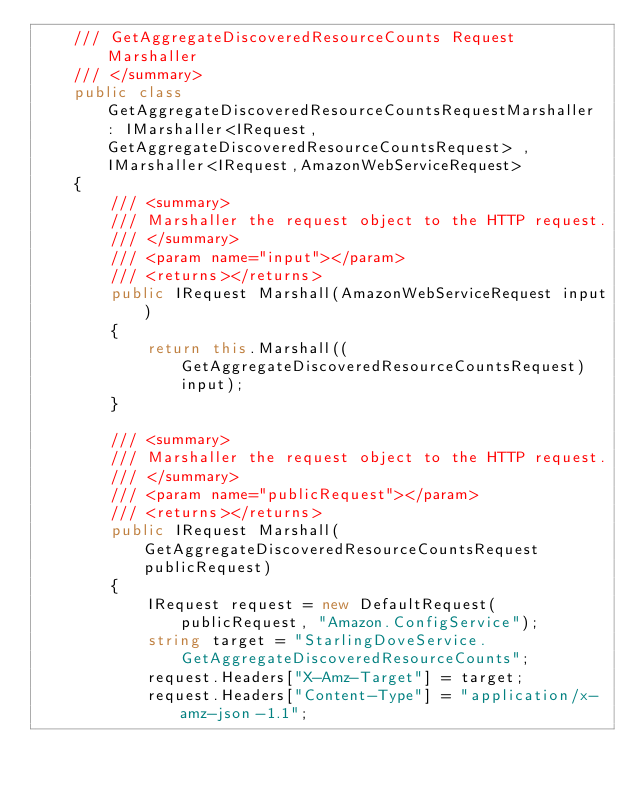Convert code to text. <code><loc_0><loc_0><loc_500><loc_500><_C#_>    /// GetAggregateDiscoveredResourceCounts Request Marshaller
    /// </summary>       
    public class GetAggregateDiscoveredResourceCountsRequestMarshaller : IMarshaller<IRequest, GetAggregateDiscoveredResourceCountsRequest> , IMarshaller<IRequest,AmazonWebServiceRequest>
    {
        /// <summary>
        /// Marshaller the request object to the HTTP request.
        /// </summary>  
        /// <param name="input"></param>
        /// <returns></returns>
        public IRequest Marshall(AmazonWebServiceRequest input)
        {
            return this.Marshall((GetAggregateDiscoveredResourceCountsRequest)input);
        }

        /// <summary>
        /// Marshaller the request object to the HTTP request.
        /// </summary>  
        /// <param name="publicRequest"></param>
        /// <returns></returns>
        public IRequest Marshall(GetAggregateDiscoveredResourceCountsRequest publicRequest)
        {
            IRequest request = new DefaultRequest(publicRequest, "Amazon.ConfigService");
            string target = "StarlingDoveService.GetAggregateDiscoveredResourceCounts";
            request.Headers["X-Amz-Target"] = target;
            request.Headers["Content-Type"] = "application/x-amz-json-1.1";</code> 